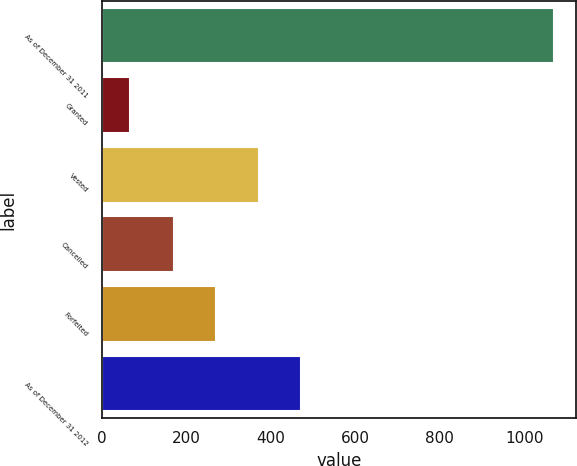Convert chart to OTSL. <chart><loc_0><loc_0><loc_500><loc_500><bar_chart><fcel>As of December 31 2011<fcel>Granted<fcel>Vested<fcel>Cancelled<fcel>Forfeited<fcel>As of December 31 2012<nl><fcel>1069<fcel>67<fcel>371.4<fcel>171<fcel>271.2<fcel>471.6<nl></chart> 